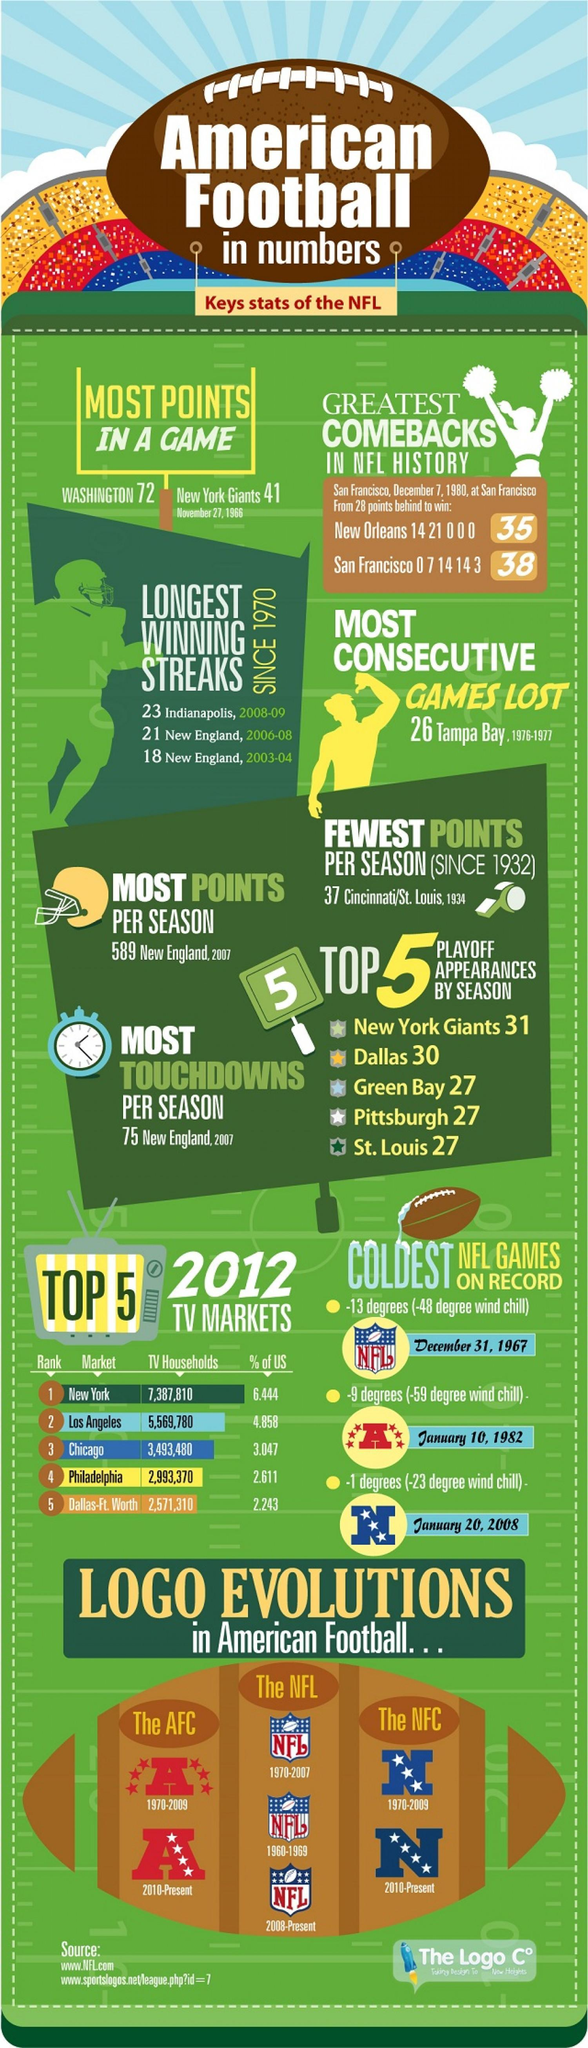When was the coldest AFC games played on record?
Answer the question with a short phrase. January 10, 1982 What is the color of the stars present in the logo of the NFC - Red, White, Blue or Yellow? White How many stars are present in the logo of the NFC from 2010-present? 4 When was the coldest NFL game played on record? December 31, 1967 What is the color of the stars present in the logo of the AFC  during 1970-2009 - White, Blue, Red or Yellow? Red What is the number of TV households in Los Angeles in 2012? 5,569,780 When was the coldest NFC games played on record? January 20, 2008 How many stars were present in the logo of the AFC during 1970-2009? 6 During which season, most consecutive games were lost by the NFL? 1976-1977 How many stars are present in the logo of the NFL from 2008-present? 8 